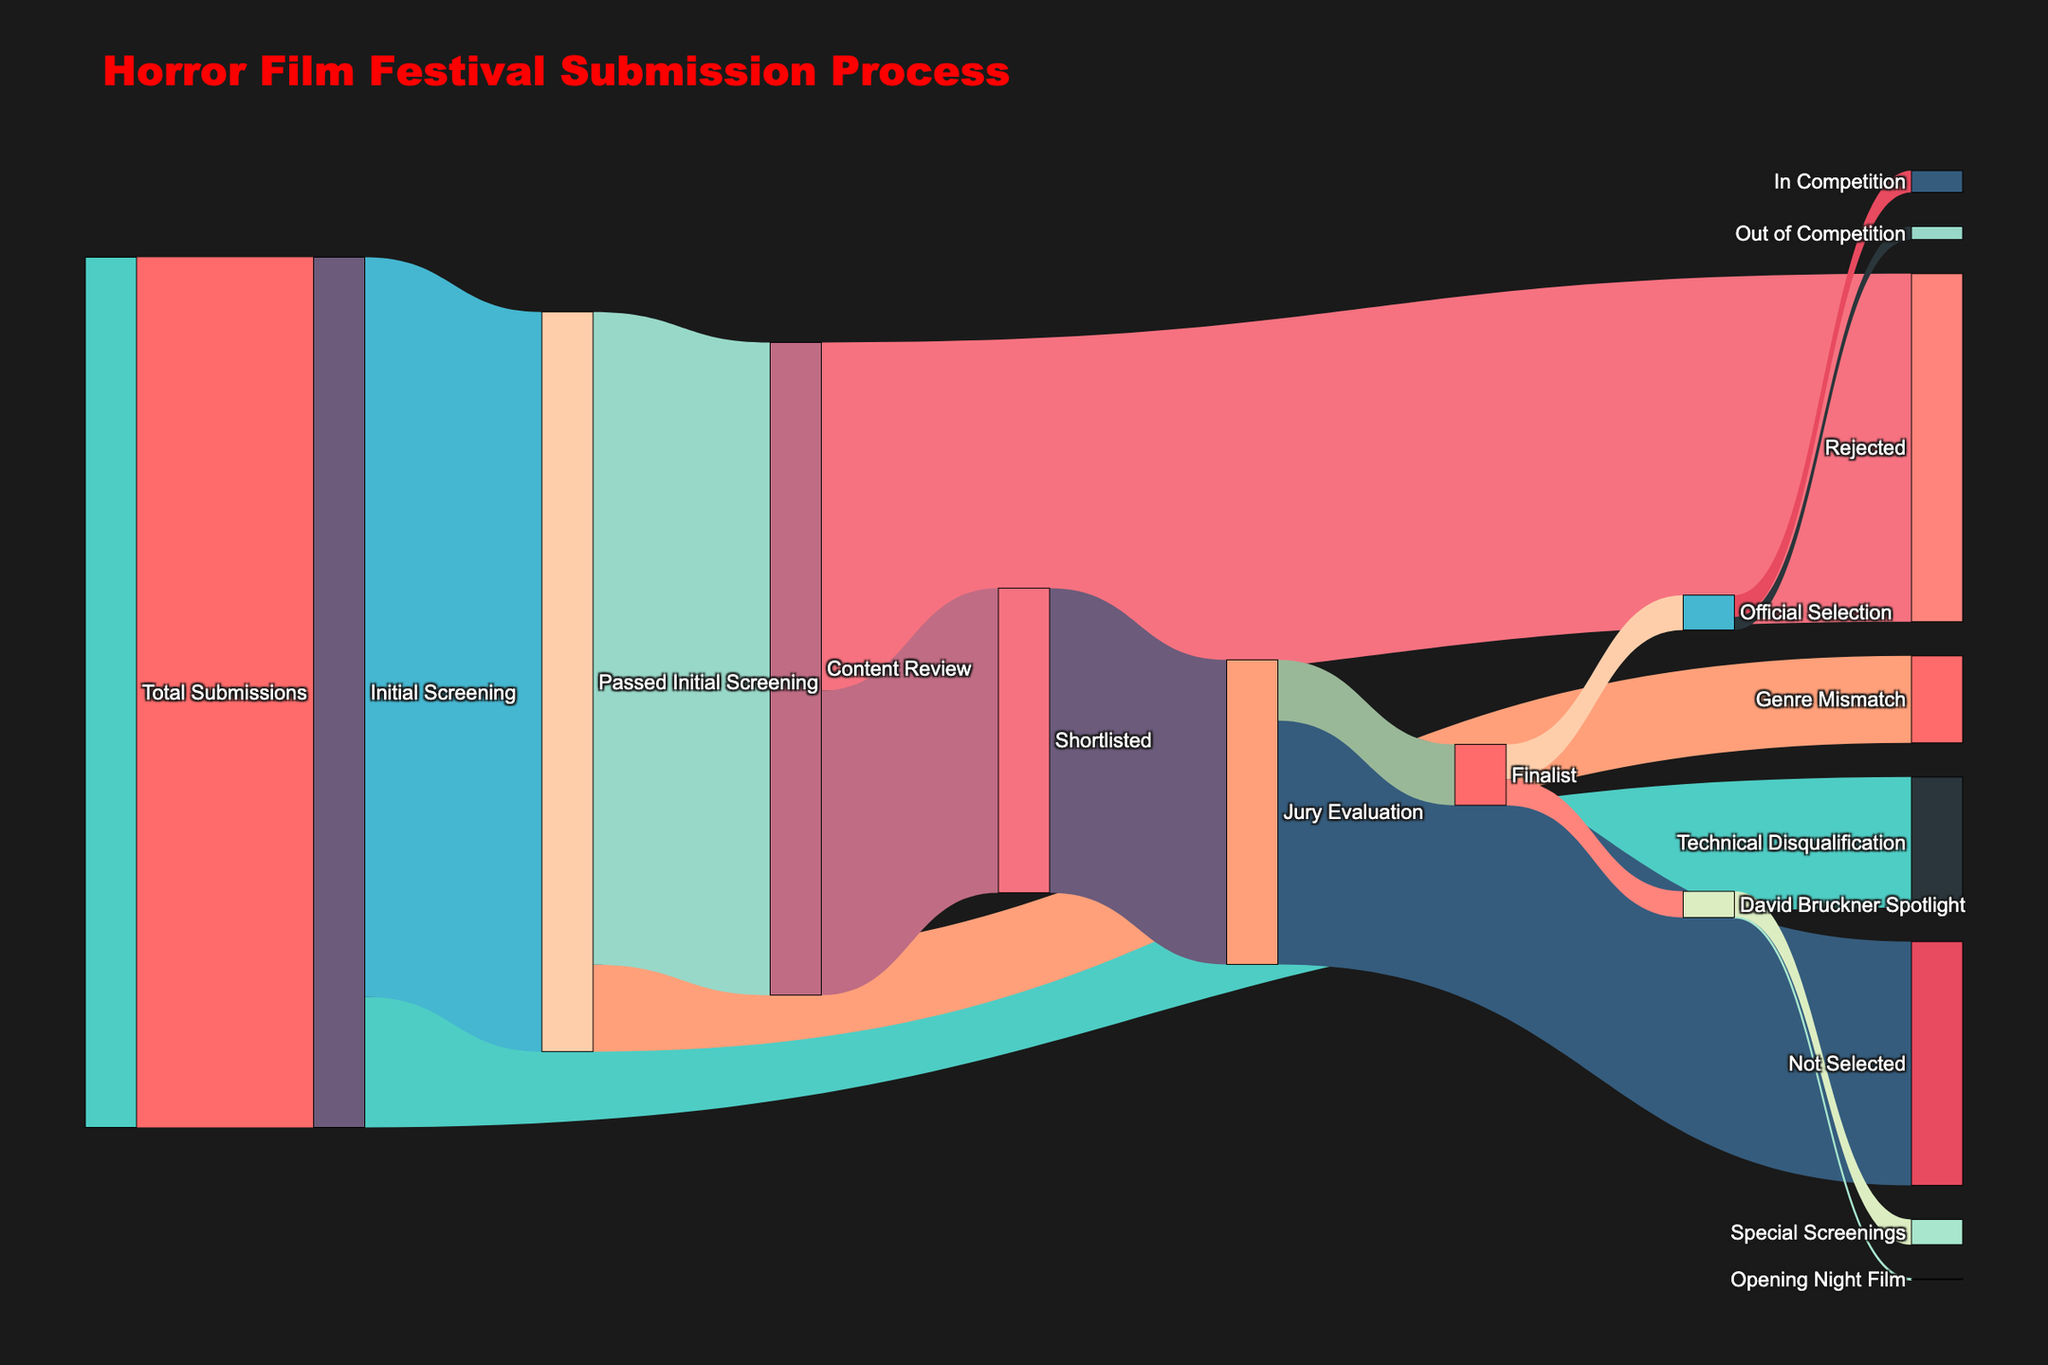what is the title of the figure? The title is located at the top of the Sankey diagram. It reads "Horror Film Festival Submission Process".
Answer: Horror Film Festival Submission Process How many submissions passed the initial screening? The Sankey diagram shows a flow from "Initial Screening" to "Passed Initial Screening" with a value of 850.
Answer: 850 Which stage eliminates the most submissions? By comparing the values, "Content Review" to "Rejected" has the highest value of 400, indicating the most submissions are eliminated at this stage.
Answer: Content Review How many films are selected for the David Bruckner Spotlight? The Sankey diagram shows that 30 submissions from the "Finalist" stage move to "David Bruckner Spotlight".
Answer: 30 What is the total number of submissions rejected before the jury evaluation? Add the values of "Technical Disqualification", "Genre Mismatch", and "Rejected": 150 + 100 + 400 = 650.
Answer: 650 How many films end up in special screenings under the David Bruckner Spotlight? The flow from "David Bruckner Spotlight" to "Special Screenings" has a value of 29.
Answer: 29 Compare the number of films in the "Official Selection" to those in the "David Bruckner Spotlight". Which is greater and by how much? 40 films are in the "Official Selection" and 30 are in the "David Bruckner Spotlight". 40 - 30 = 10.
Answer: Official Selection by 10 What proportion of the shortlisted films are selected as finalists? There are 350 shortlisted films and 70 become finalists. The proportion is 70 / 350 = 0.2 or 20%.
Answer: 20% How many films pass both the initial screening and the content review? The value from "Initial Screening" to "Passed Initial Screening" is 850, and from "Passed Initial Screening" to "Content Review" is 750.
Answer: 750 What is the outcome for the highest number of finalists? Compare the values under the "Finalist" stage: "Official Selection" (40) and "David Bruckner Spotlight" (30). The "Official Selection" has the highest number with 40 finalists.
Answer: Official Selection 